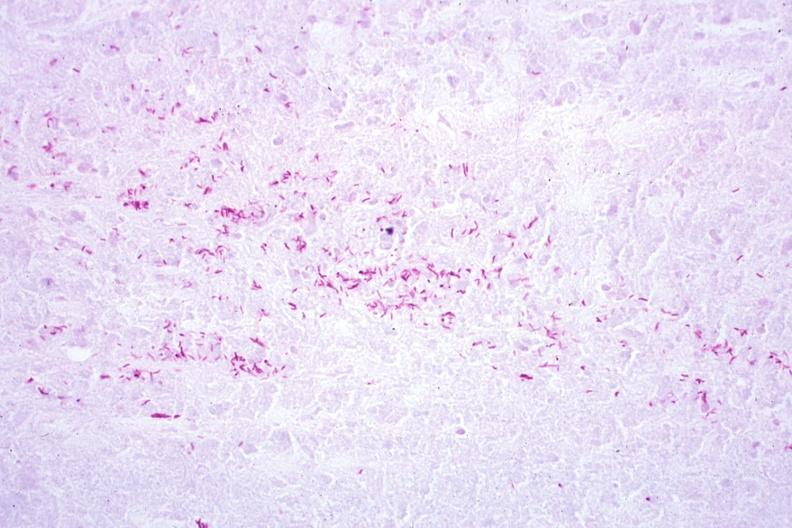what is present?
Answer the question using a single word or phrase. Tuberculosis 